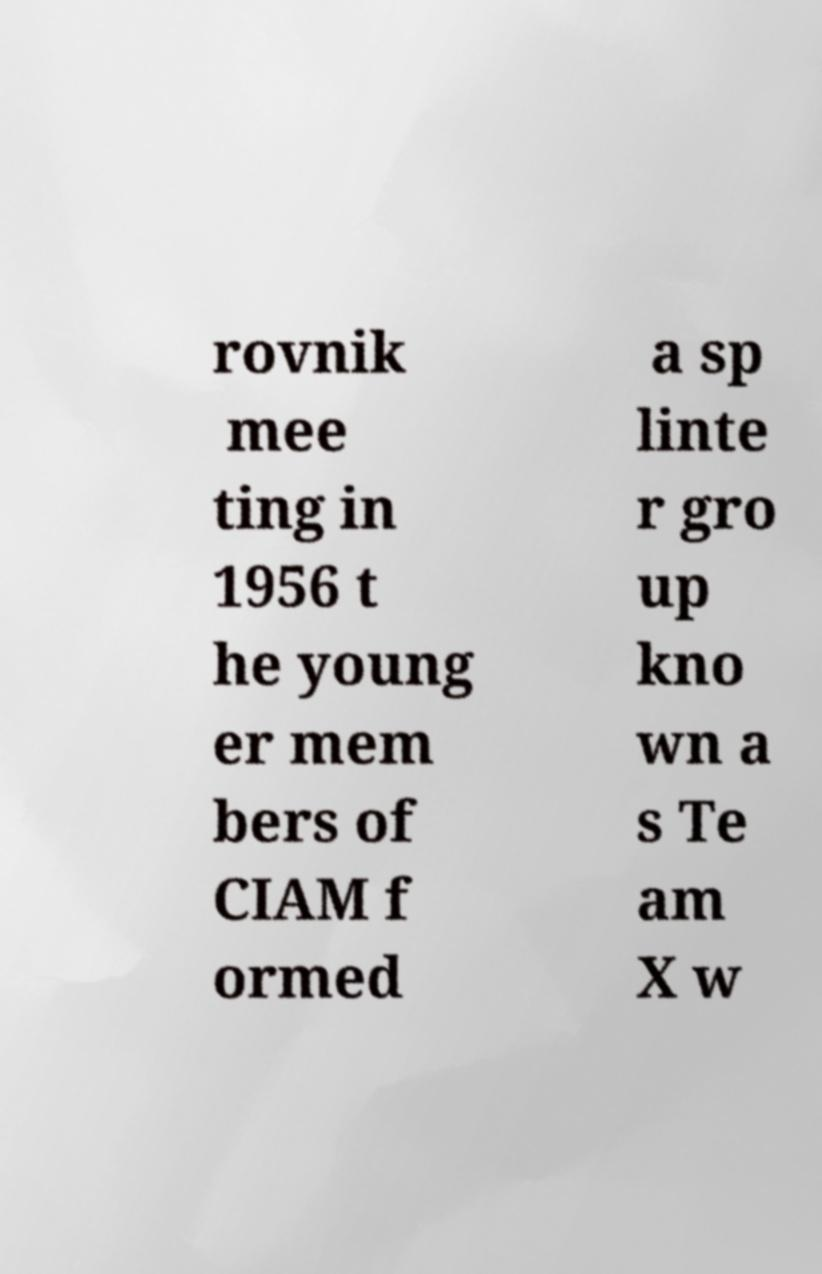Please identify and transcribe the text found in this image. rovnik mee ting in 1956 t he young er mem bers of CIAM f ormed a sp linte r gro up kno wn a s Te am X w 